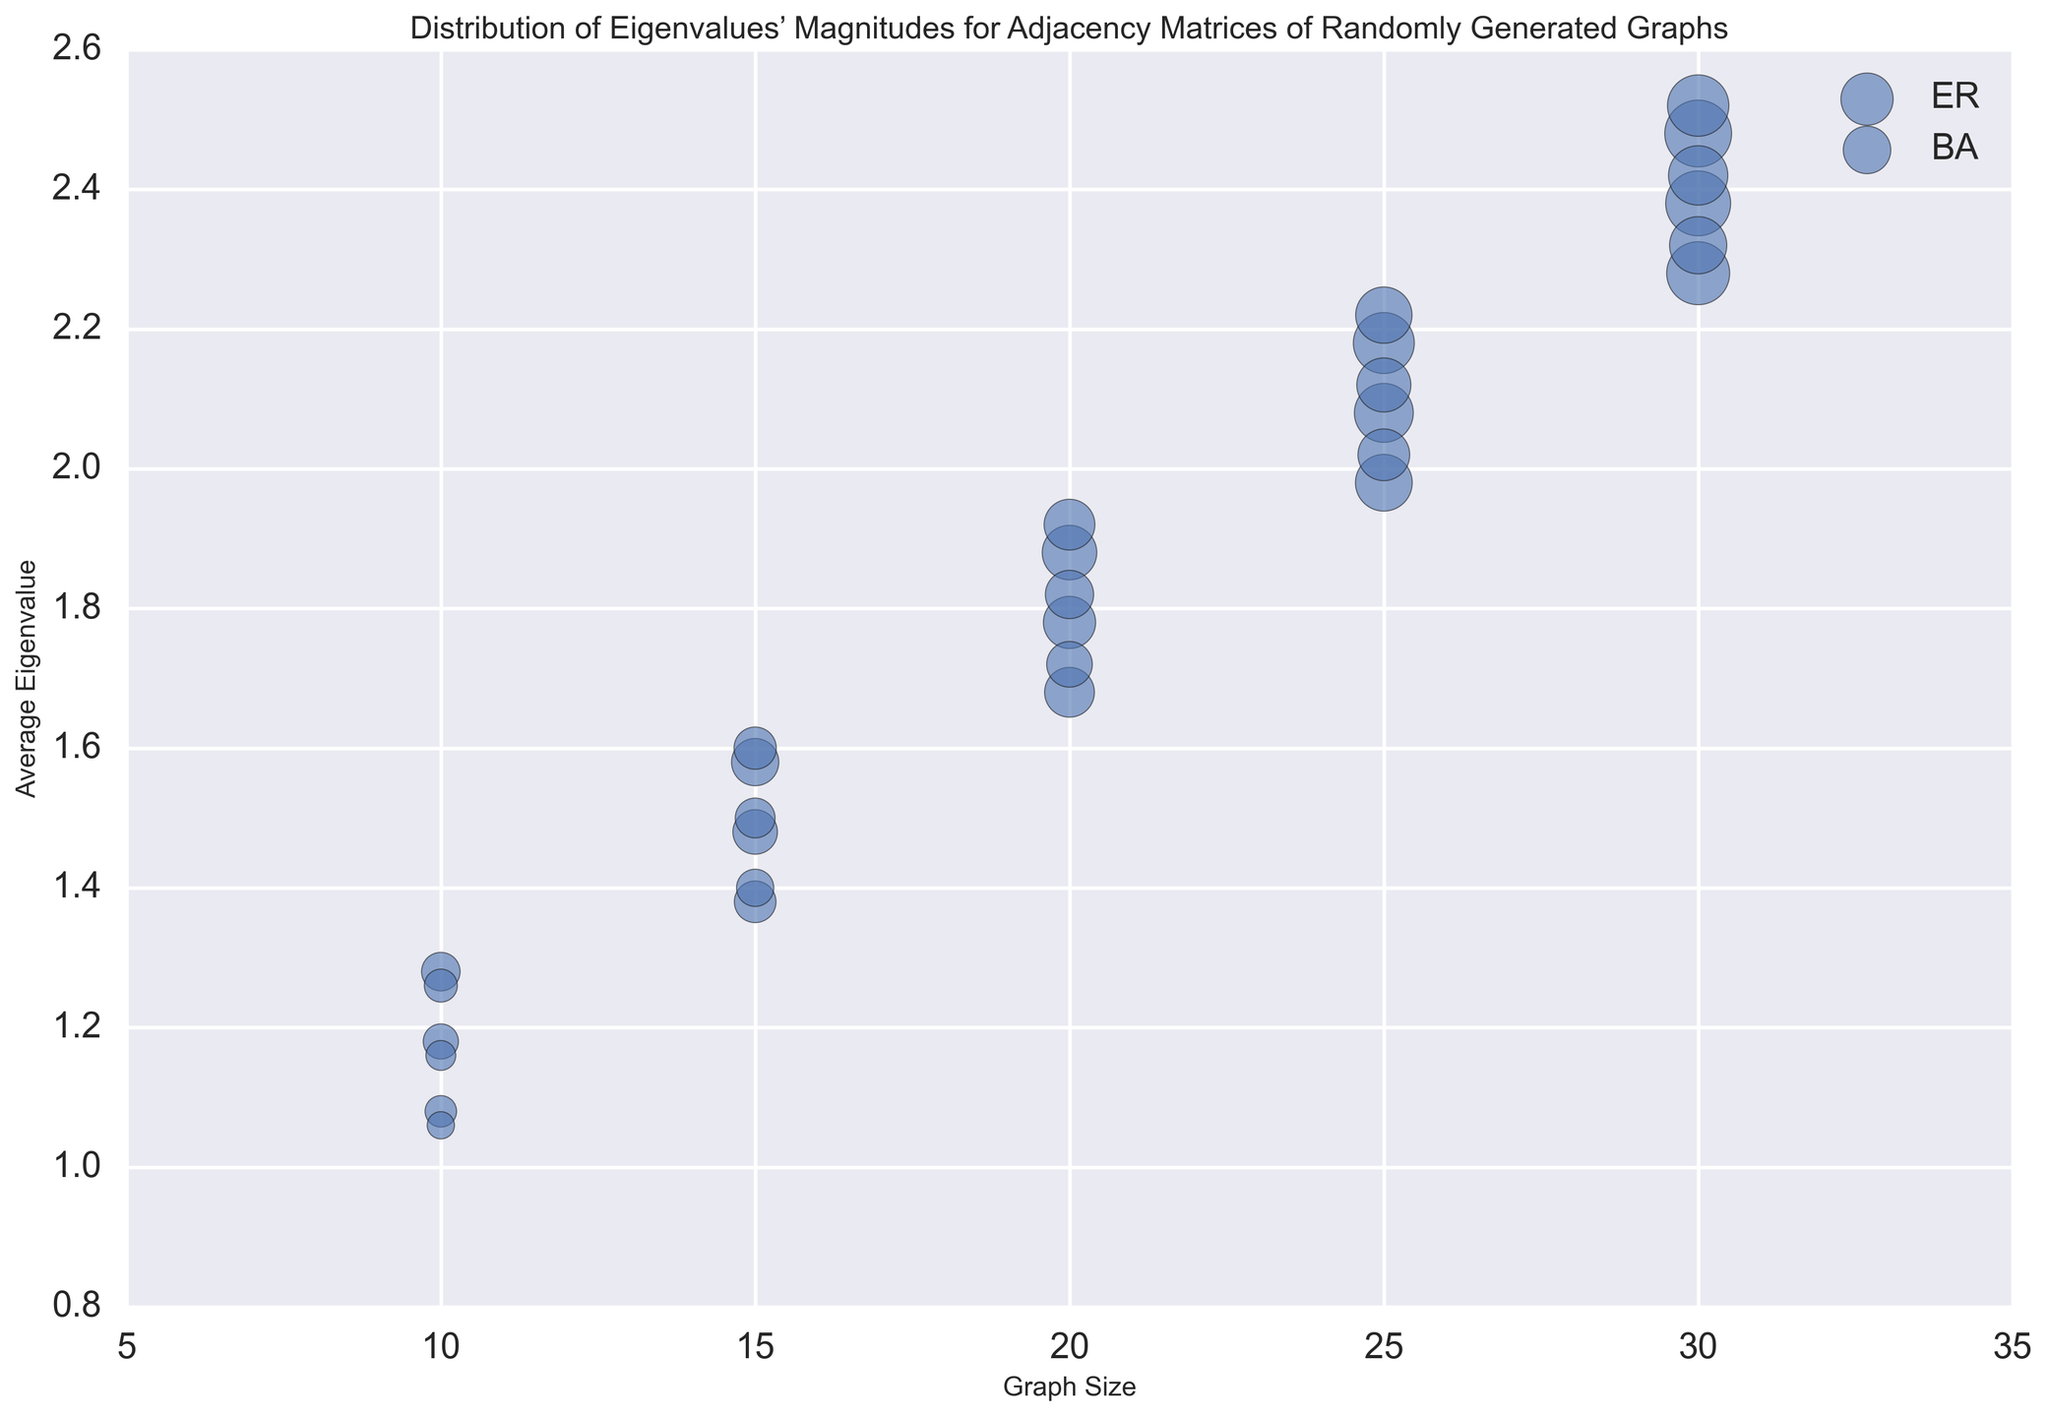What's the average eigenvalue for Graph Size 10 and Graph Type ER? First, identify the relevant data points: (1.2 + 0.9 + 1.5 + 0.7 + 1.1) / 5 = 1.08, (1.3 + 1.0 + 1.6 + 0.8 + 1.2) / 5 = 1.18, (1.4 + 1.1 + 1.7 + 0.9 + 1.3) / 5 = 1.28. Then compute the average: (1.08 + 1.18 + 1.28) / 3 = 1.18.
Answer: 1.18 Which graph type has larger average eigenvalues when Graph Size is 20? Look at the y-values for Graph Size 20 for both ER and BA: (1.8 + 1.5 + 2.1 + 1.4 + 1.6) / 5 = 1.68 for ER and (1.6 + 1.9 + 1.4 + 2.2 + 1.5) / 5 = 1.72 for BA. Compare the two average values: 1.68 < 1.72.
Answer: BA For Graph Size 15, how much larger is the bubble size for ER compared to BA? Average Bubble Size for ER when Graph Size is 15: (35 + 40 + 45) / 3 = 40. Average Bubble Size for BA when Graph Size is 15: (28 + 32 + 36) / 3 = 32.67. Difference: 40 - 32.67 = 7.33.
Answer: 7.33 Does Graph Type ER or BA have a higher maximum average eigenvalue in the whole dataset? For ER, the max average eigenvalue is at Graph Size 30: (2.4 + 2.1 + 2.7 + 2.0 + 2.2) / 5 = 2.28. For BA, the max average eigenvalue is also at Graph Size 30: (2.2 + 2.5 + 2.0 + 2.8 + 2.1) / 5 = 2.32. Compare the two: 2.32 > 2.28.
Answer: BA What is the general trend of average eigenvalue with increasing Graph Size? By observing the plot, you can see that as Graph Size increases, the average eigenvalue also increases. This trend is consistent for both ER and BA types.
Answer: Increasing What's the maximum Bubble Size for Graph Type ER? Locate the data points for Graph Type ER and identify the largest Bubble Size. The maximum bubble size is: 90.
Answer: 90 When Graph Size is 25, which graph type has more variability in average eigenvalues? Compare the range of average eigenvalues for Graph Size 25. For ER: [(2.1 + 1.8 + 2.4 + 1.7 + 1.9) / 5] to [(2.3 + 2.0 + 2.6 + 1.9 + 2.1) / 5]. For BA: [(1.9 + 2.2 + 1.7 + 2.5 + 1.8) / 5] to [(2.1 + 2.4 + 1.9 + 2.7 + 2.0) / 5]. Variability: ER = 0.21, BA = 0.20.
Answer: ER 